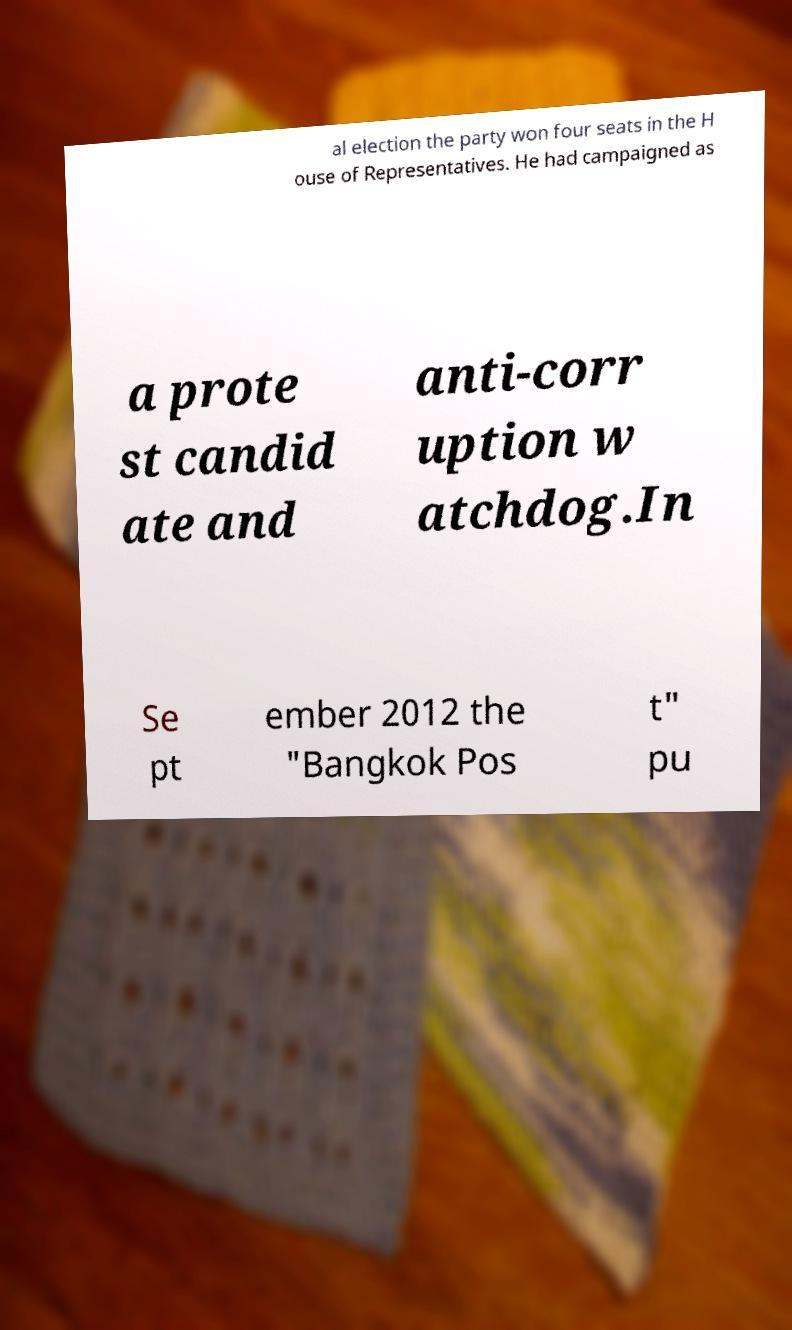For documentation purposes, I need the text within this image transcribed. Could you provide that? al election the party won four seats in the H ouse of Representatives. He had campaigned as a prote st candid ate and anti-corr uption w atchdog.In Se pt ember 2012 the "Bangkok Pos t" pu 